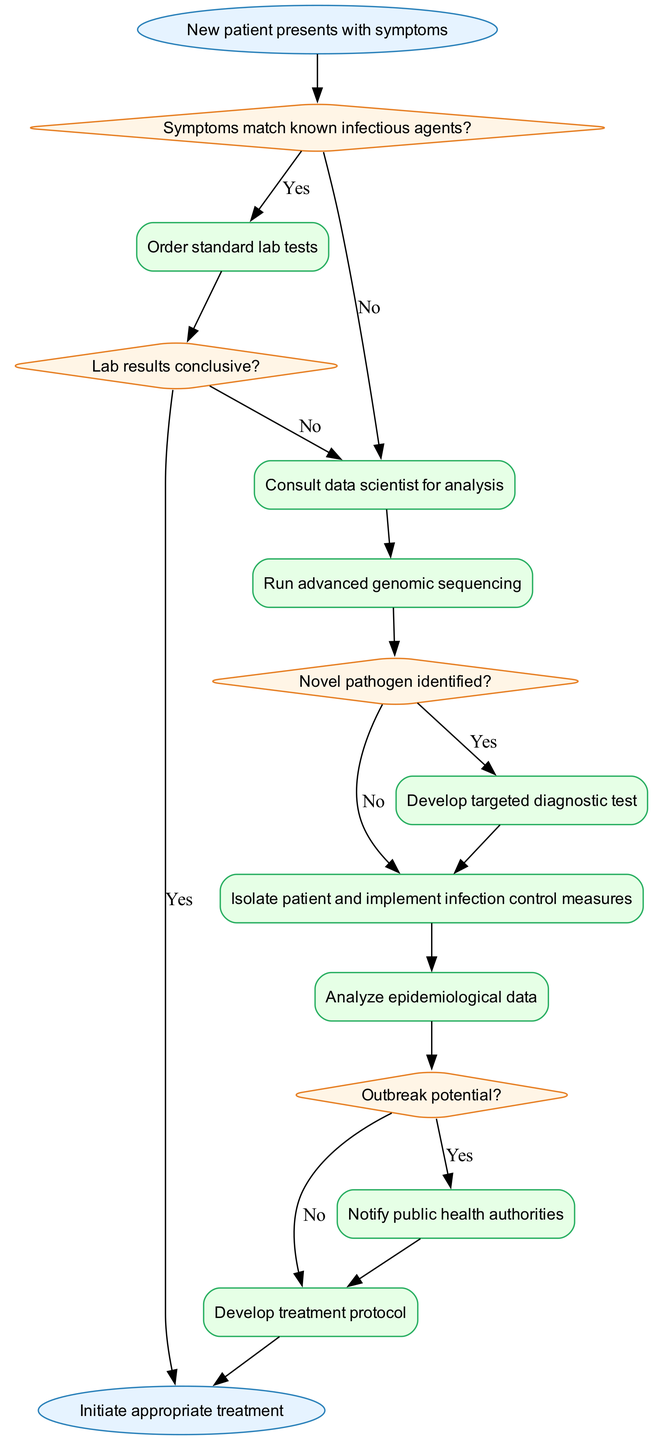What's the first step in the diagnosis algorithm? The diagram starts with the node labeled "New patient presents with symptoms," indicating the initial action taken in the diagnosis process.
Answer: New patient presents with symptoms How many decision nodes are present in the diagram? The diagram contains four decision nodes: "Symptoms match known infectious agents?", "Lab results conclusive?", "Novel pathogen identified?", and "Outbreak potential?" This leads to a total of four decision points.
Answer: Four What do we do if lab results are not conclusive? If lab results are not conclusive (indicated by the "No" branch from the "Lab results conclusive?" decision node), the next process is to "Consult data scientist for analysis."
Answer: Consult data scientist for analysis What happens after a novel pathogen is identified? Once a novel pathogen is identified (following the "Yes" from the "Novel pathogen identified?" decision node), the next steps include "Develop targeted diagnostic test" and "Isolate patient and implement infection control measures."
Answer: Develop targeted diagnostic test, Isolate patient and implement infection control measures If there is an outbreak potential, what is the next action? If an outbreak potential is identified ("Yes" from the "Outbreak potential?" decision node), the following action is to "Notify public health authorities."
Answer: Notify public health authorities What is the final step in the algorithm? The last node in the diagram is labeled "Initiate appropriate treatment," which signifies the final action that concludes the diagnostic process.
Answer: Initiate appropriate treatment What process follows after isolating the patient? After isolating the patient (following the "Isolate patient and implement infection control measures" process), the next step is to "Analyze epidemiological data."
Answer: Analyze epidemiological data What is the relationship between the "Consult data scientist for analysis" and "Run advanced genomic sequencing"? The "Consult data scientist for analysis" process leads directly to the "Run advanced genomic sequencing" process, indicating that this advanced step is taken after consultation.
Answer: Leads directly to 